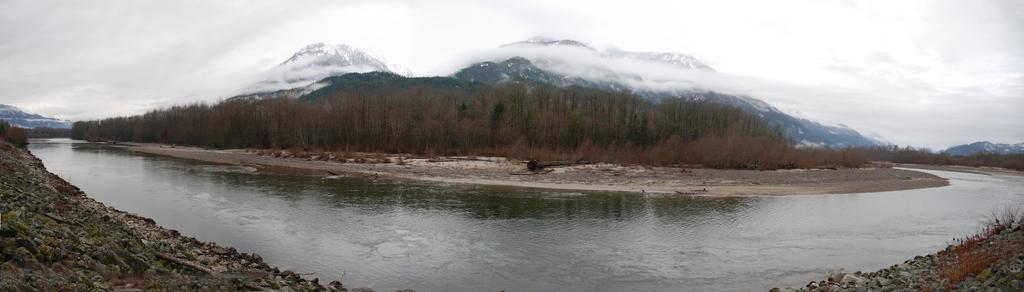Where was the picture taken? The picture was clicked outside the city. What can be seen in the foreground of the image? There are rocks and a water body in the foreground. What is visible in the background of the image? The sky is visible in the background, along with hills and trees. What is the aftermath of the expansion in the image? There is no mention of expansion in the image, so it is not possible to discuss its aftermath. 